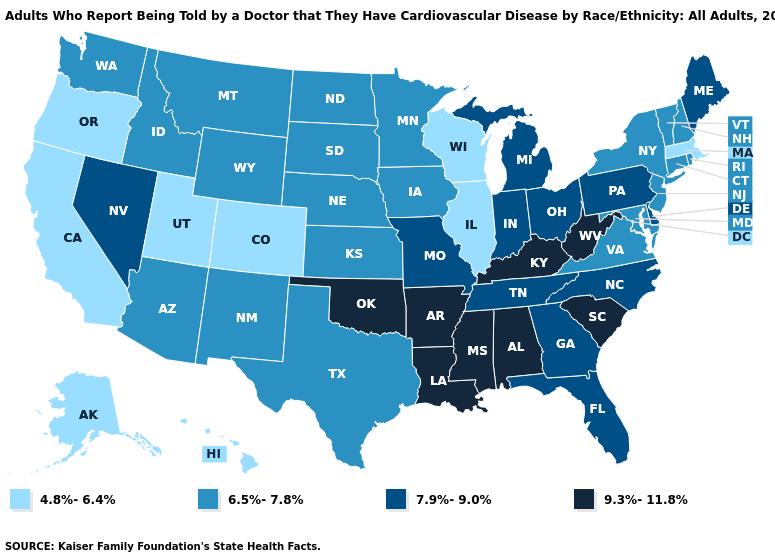Name the states that have a value in the range 7.9%-9.0%?
Write a very short answer. Delaware, Florida, Georgia, Indiana, Maine, Michigan, Missouri, Nevada, North Carolina, Ohio, Pennsylvania, Tennessee. Does the first symbol in the legend represent the smallest category?
Write a very short answer. Yes. Which states have the lowest value in the USA?
Give a very brief answer. Alaska, California, Colorado, Hawaii, Illinois, Massachusetts, Oregon, Utah, Wisconsin. Name the states that have a value in the range 6.5%-7.8%?
Give a very brief answer. Arizona, Connecticut, Idaho, Iowa, Kansas, Maryland, Minnesota, Montana, Nebraska, New Hampshire, New Jersey, New Mexico, New York, North Dakota, Rhode Island, South Dakota, Texas, Vermont, Virginia, Washington, Wyoming. Name the states that have a value in the range 4.8%-6.4%?
Quick response, please. Alaska, California, Colorado, Hawaii, Illinois, Massachusetts, Oregon, Utah, Wisconsin. Does the map have missing data?
Short answer required. No. Among the states that border Colorado , does Wyoming have the highest value?
Be succinct. No. Does the map have missing data?
Quick response, please. No. Among the states that border Pennsylvania , which have the lowest value?
Answer briefly. Maryland, New Jersey, New York. Which states have the lowest value in the USA?
Give a very brief answer. Alaska, California, Colorado, Hawaii, Illinois, Massachusetts, Oregon, Utah, Wisconsin. What is the value of Oregon?
Quick response, please. 4.8%-6.4%. Does Illinois have the lowest value in the USA?
Short answer required. Yes. What is the lowest value in the Northeast?
Short answer required. 4.8%-6.4%. What is the highest value in states that border Wisconsin?
Short answer required. 7.9%-9.0%. Among the states that border Tennessee , which have the highest value?
Be succinct. Alabama, Arkansas, Kentucky, Mississippi. 